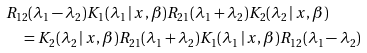<formula> <loc_0><loc_0><loc_500><loc_500>& R _ { 1 2 } ( \lambda _ { 1 } - \lambda _ { 2 } ) K _ { 1 } ( \lambda _ { 1 } \, | \, x , \beta ) R _ { 2 1 } ( \lambda _ { 1 } + \lambda _ { 2 } ) K _ { 2 } ( \lambda _ { 2 } \, | \, x , \beta ) \\ & \quad = K _ { 2 } ( \lambda _ { 2 } \, | \, x , \beta ) R _ { 2 1 } ( \lambda _ { 1 } + \lambda _ { 2 } ) K _ { 1 } ( \lambda _ { 1 } \, | \, x , \beta ) R _ { 1 2 } ( \lambda _ { 1 } - \lambda _ { 2 } )</formula> 